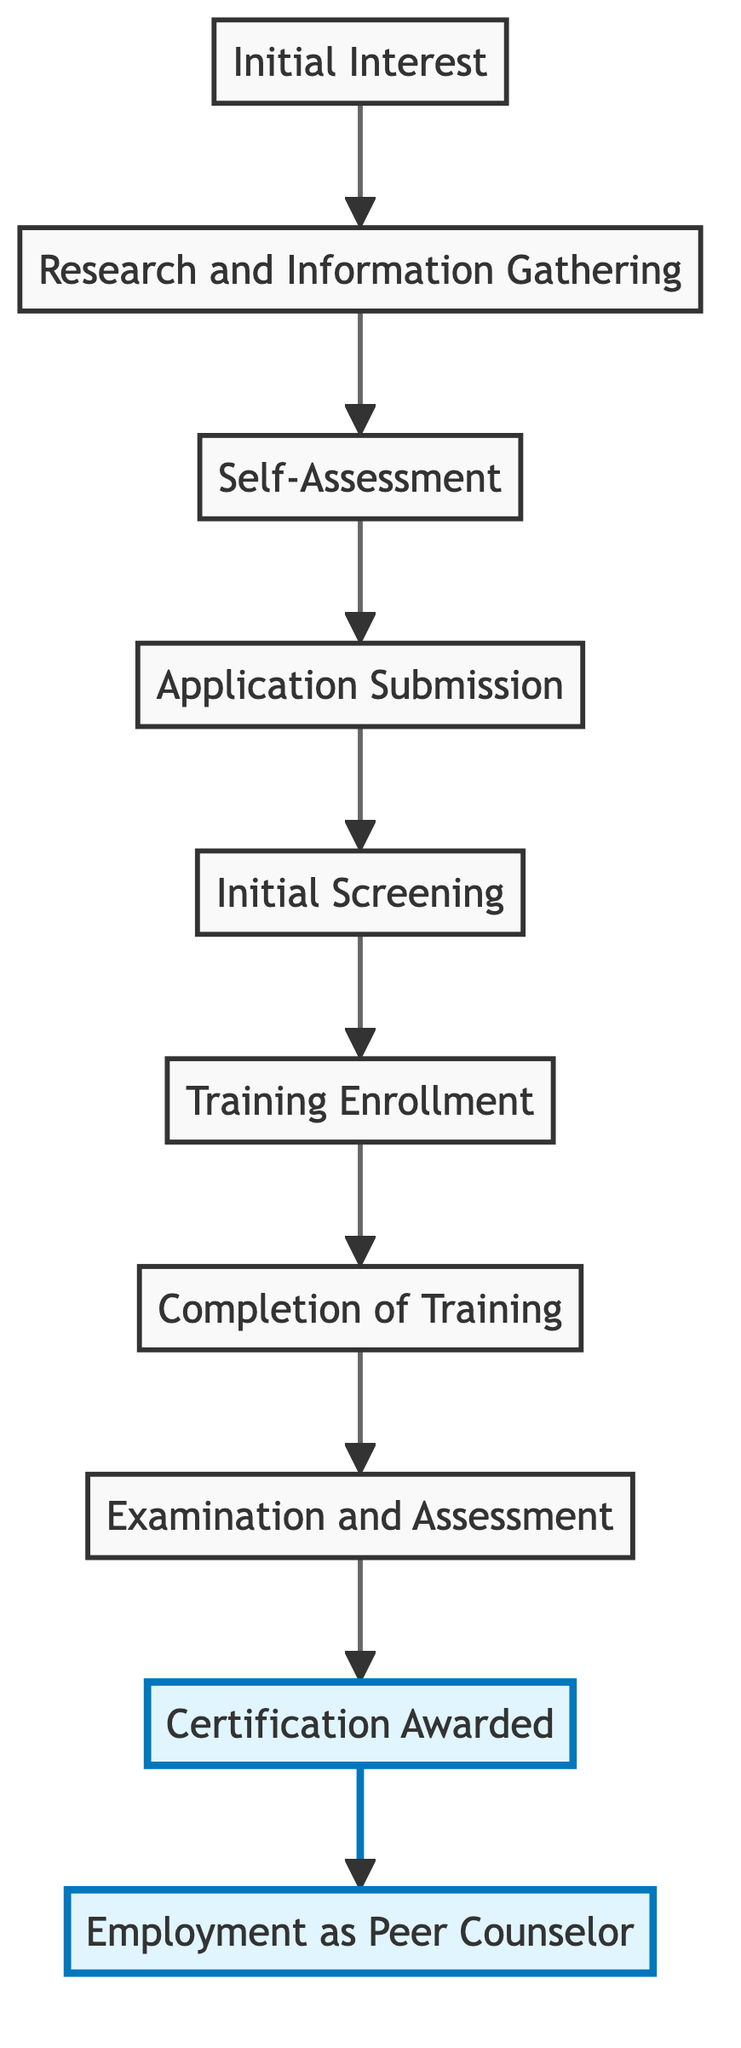What is the first step in the pathway? The first step in the pathway is indicated at the bottom of the diagram as "Initial Interest". It is the starting point where the Veteran expresses interest in becoming a Peer Counselor.
Answer: Initial Interest How many nodes are present in the flowchart? The flowchart contains a total of ten nodes, each representing a step in the pathway to becoming a Certified Peer Counselor.
Answer: 10 What is the last step in the pathway? The last step is "Employment as Peer Counselor," which is the final outcome of the certification process as indicated at the top of the diagram.
Answer: Employment as Peer Counselor Which step follows "Training Enrollment"? "Completion of Training" directly follows "Training Enrollment" in the sequence of steps outlined in the flowchart.
Answer: Completion of Training What important milestone occurs after "Certification Awarded"? The milestone that occurs after "Certification Awarded" is the beginning of "Employment as Peer Counselor," indicating a transition from certification to actual employment.
Answer: Employment as Peer Counselor If a veteran is at the "Application Submission" stage, what is the preceding step? The step preceding "Application Submission" is "Self-Assessment," which is crucial for determining readiness before submitting the application.
Answer: Self-Assessment Which two steps are highlighted in the diagram? The two highlighted steps in the diagram are "Certification Awarded" and "Employment as Peer Counselor," indicating their importance in the overall process.
Answer: Certification Awarded, Employment as Peer Counselor What step requires passing exams? "Examination and Assessment" is the specific step that requires the veteran to pass necessary exams and practical assessments as part of the pathway.
Answer: Examination and Assessment In the flowchart, what comes immediately before "Initial Screening"? "Application Submission" comes immediately before "Initial Screening," indicating that the application is reviewed after it has been submitted.
Answer: Application Submission What is the role of "Research and Information Gathering" in the pathway? "Research and Information Gathering" is foundational as it helps the veteran understand the requirements and responsibilities associated with becoming a Peer Counselor, making it critical for informed decision-making in the process.
Answer: Research and Information Gathering 